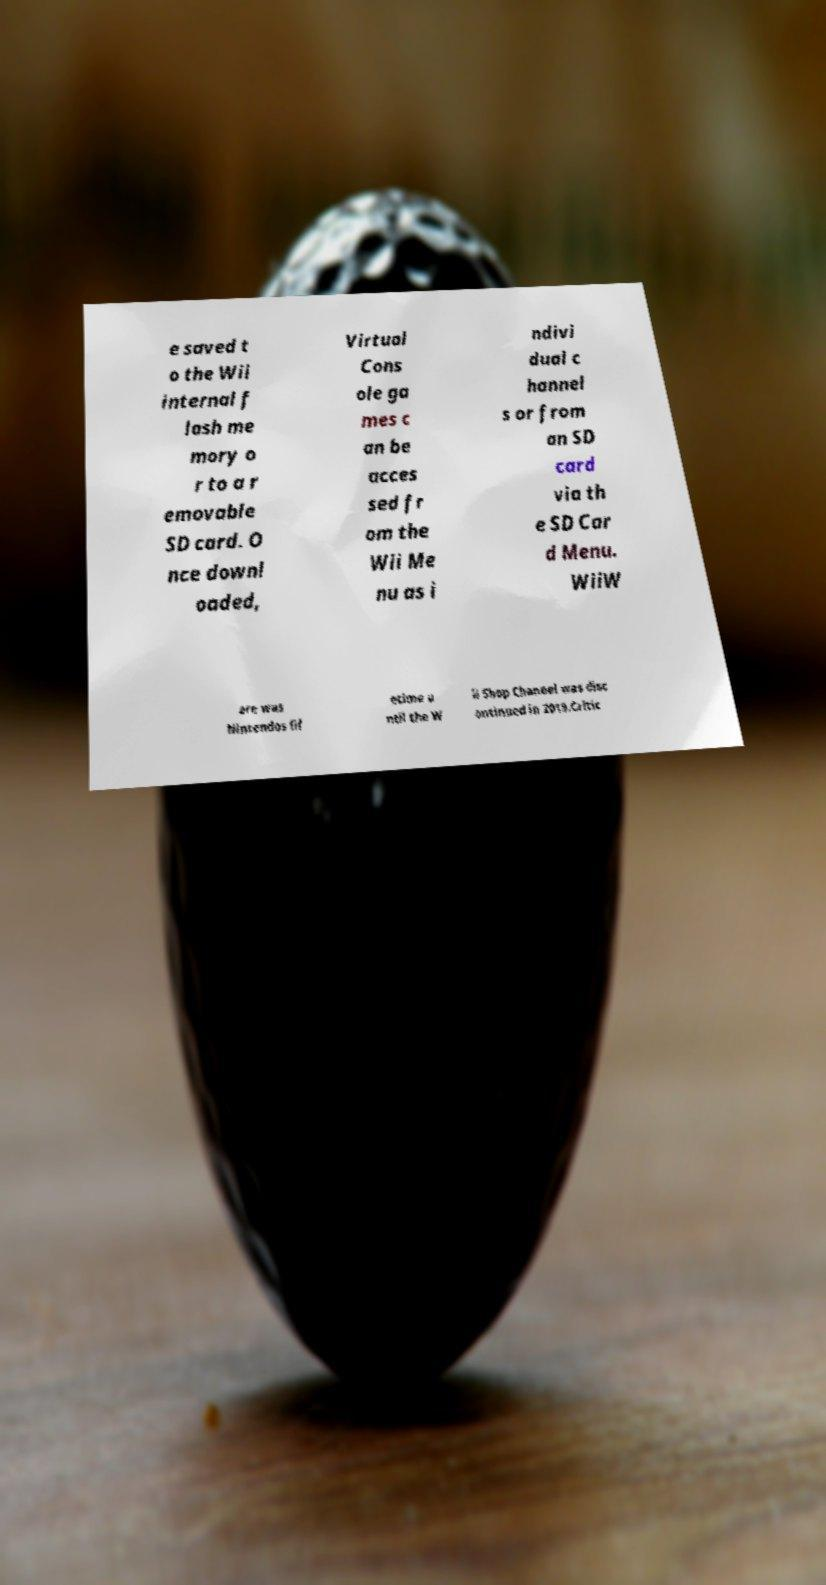What messages or text are displayed in this image? I need them in a readable, typed format. e saved t o the Wii internal f lash me mory o r to a r emovable SD card. O nce downl oaded, Virtual Cons ole ga mes c an be acces sed fr om the Wii Me nu as i ndivi dual c hannel s or from an SD card via th e SD Car d Menu. WiiW are was Nintendos lif etime u ntil the W ii Shop Channel was disc ontinued in 2019.Critic 